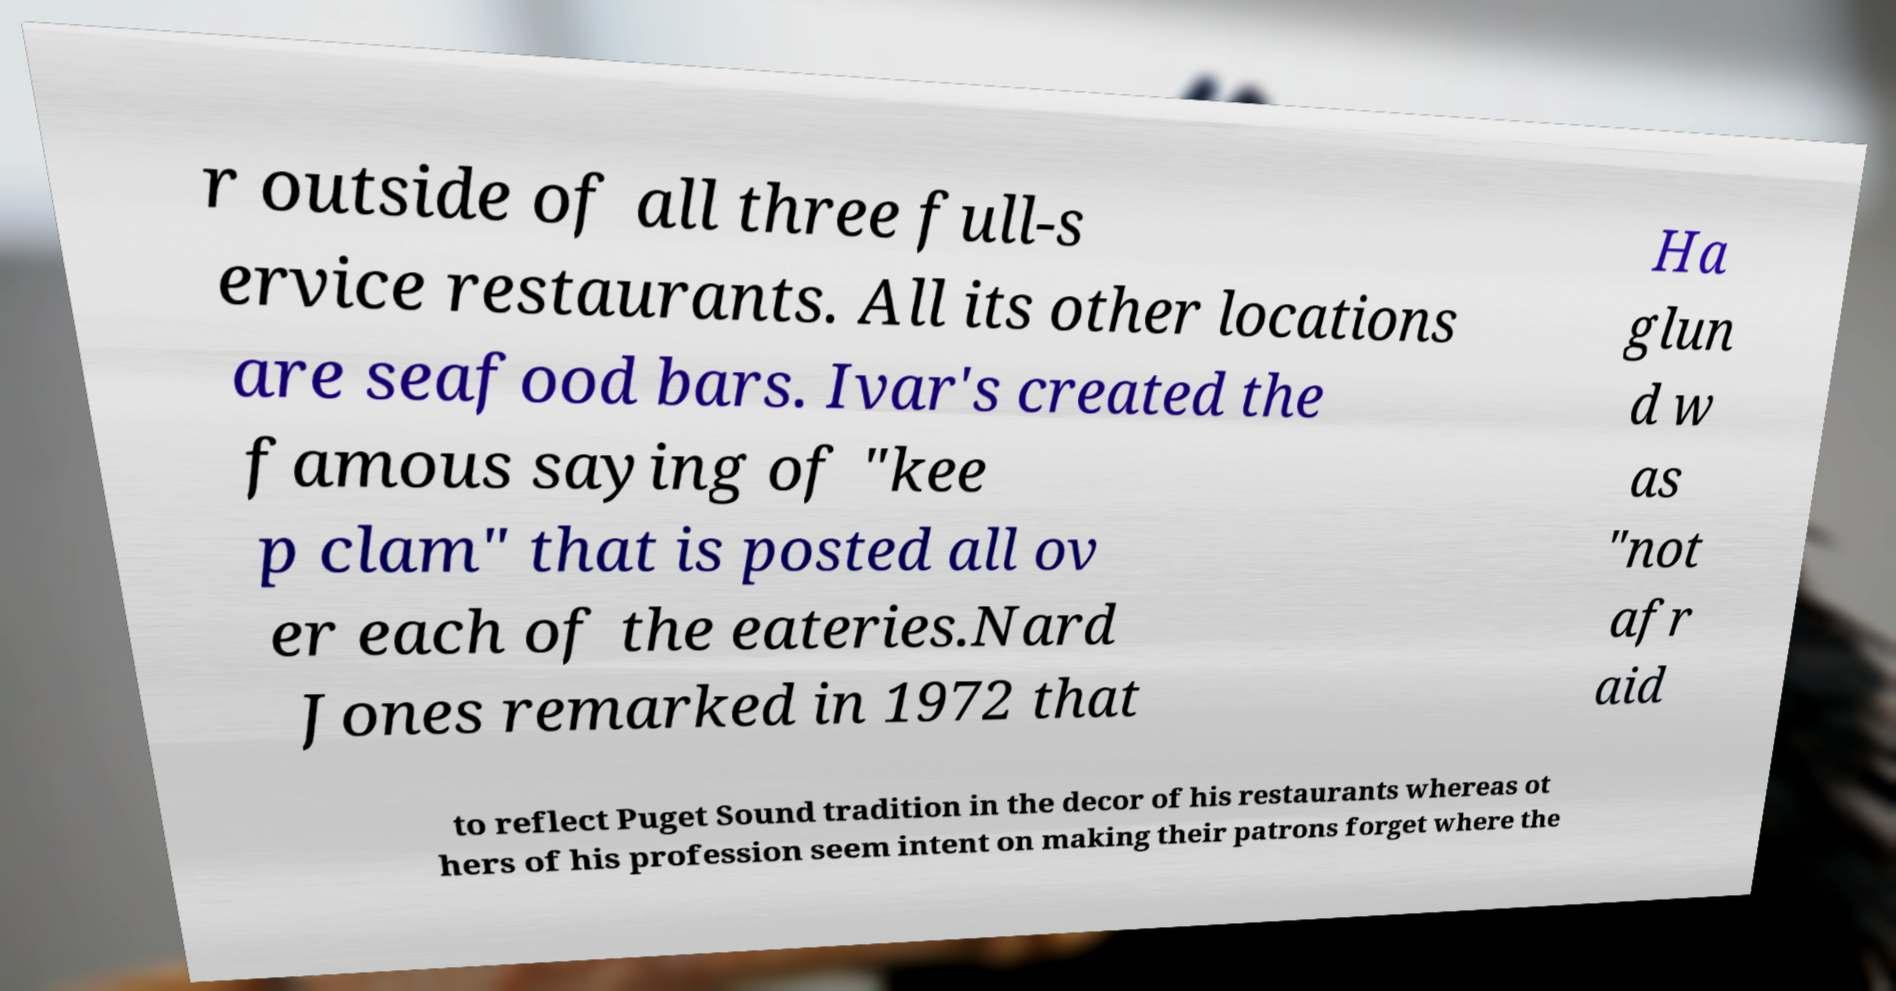What messages or text are displayed in this image? I need them in a readable, typed format. r outside of all three full-s ervice restaurants. All its other locations are seafood bars. Ivar's created the famous saying of "kee p clam" that is posted all ov er each of the eateries.Nard Jones remarked in 1972 that Ha glun d w as "not afr aid to reflect Puget Sound tradition in the decor of his restaurants whereas ot hers of his profession seem intent on making their patrons forget where the 